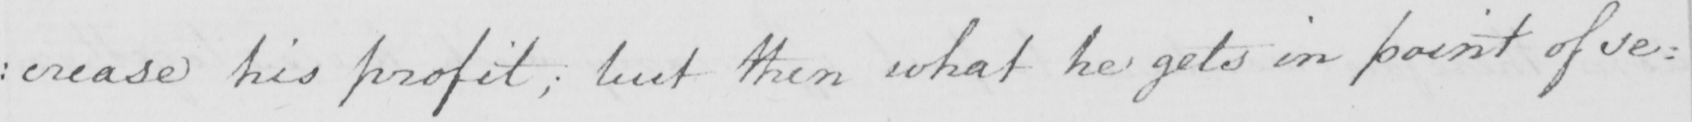Can you tell me what this handwritten text says? : crease his profit ; but then what he gets in point of se= 